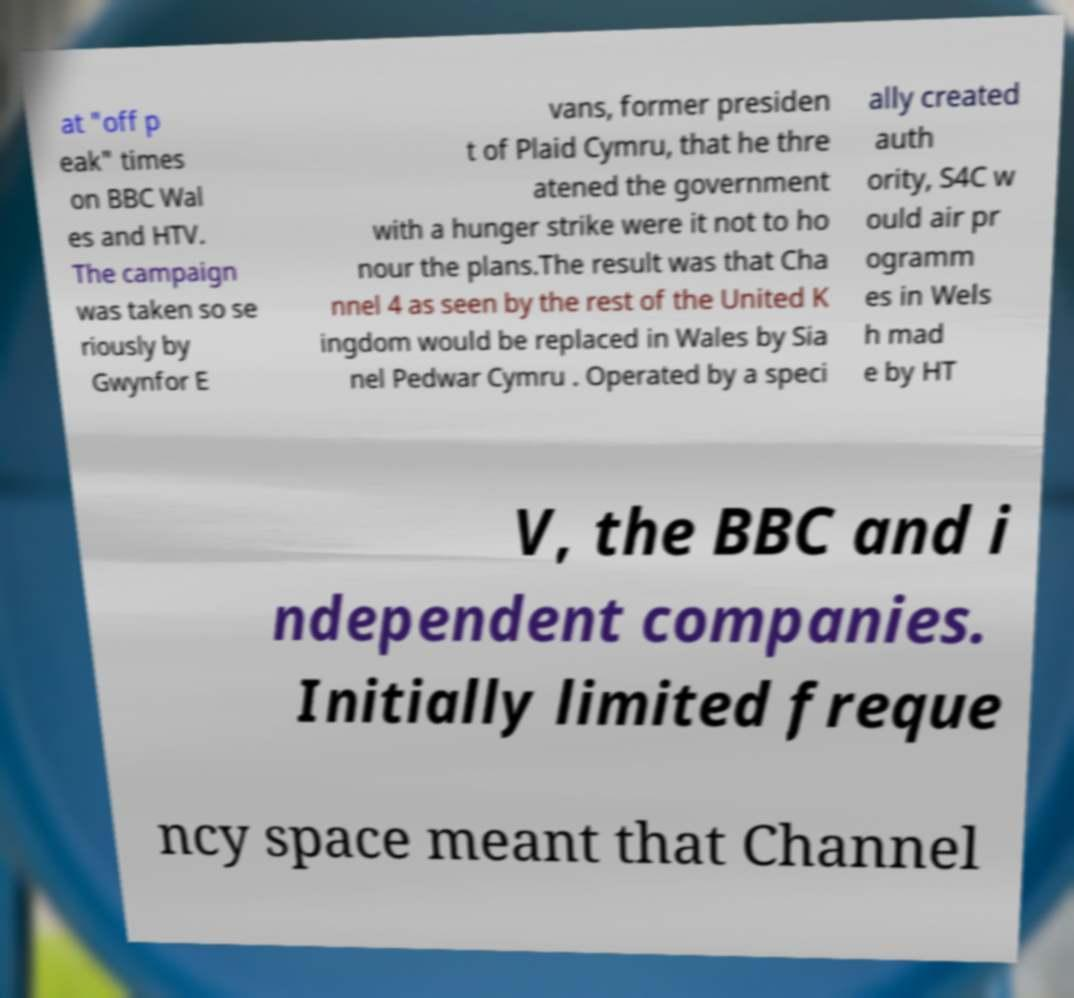Can you accurately transcribe the text from the provided image for me? at "off p eak" times on BBC Wal es and HTV. The campaign was taken so se riously by Gwynfor E vans, former presiden t of Plaid Cymru, that he thre atened the government with a hunger strike were it not to ho nour the plans.The result was that Cha nnel 4 as seen by the rest of the United K ingdom would be replaced in Wales by Sia nel Pedwar Cymru . Operated by a speci ally created auth ority, S4C w ould air pr ogramm es in Wels h mad e by HT V, the BBC and i ndependent companies. Initially limited freque ncy space meant that Channel 